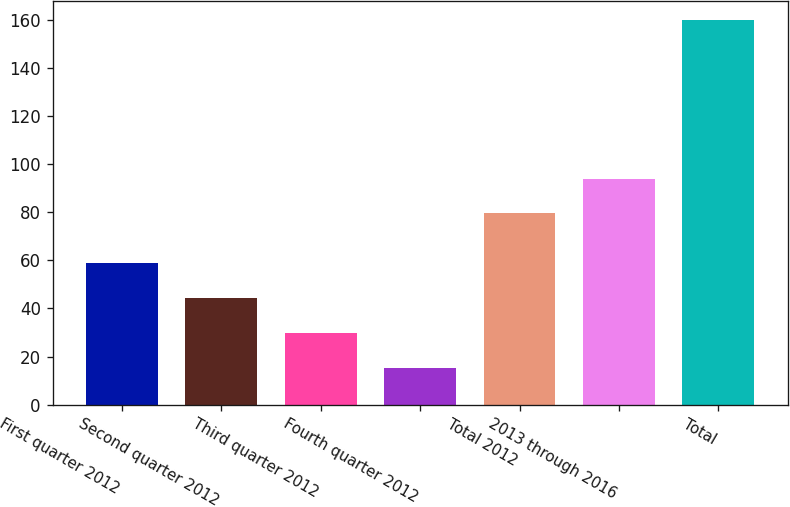<chart> <loc_0><loc_0><loc_500><loc_500><bar_chart><fcel>First quarter 2012<fcel>Second quarter 2012<fcel>Third quarter 2012<fcel>Fourth quarter 2012<fcel>Total 2012<fcel>2013 through 2016<fcel>Total<nl><fcel>58.68<fcel>44.22<fcel>29.76<fcel>15.3<fcel>79.5<fcel>93.96<fcel>159.9<nl></chart> 